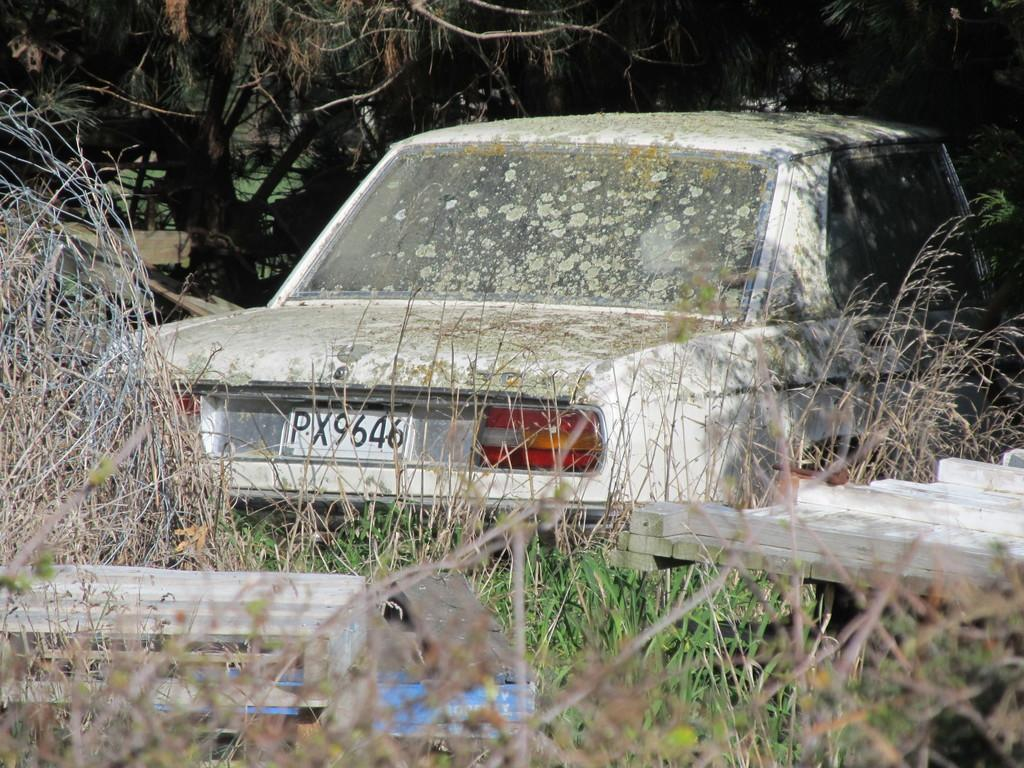What is the main subject of the image? The main subject of the image is a car. Can you describe the car in the image? The car is white. What can be seen on the ground in the image? There are plants and grass on the ground. What is visible in the background of the image? There are trees in the background. What type of advertisement can be seen on the car in the image? There is no advertisement visible on the car in the image; it is simply a white car. What kind of soap is being used to wash the car in the image? There is no indication that the car is being washed in the image, and therefore no soap can be observed. 